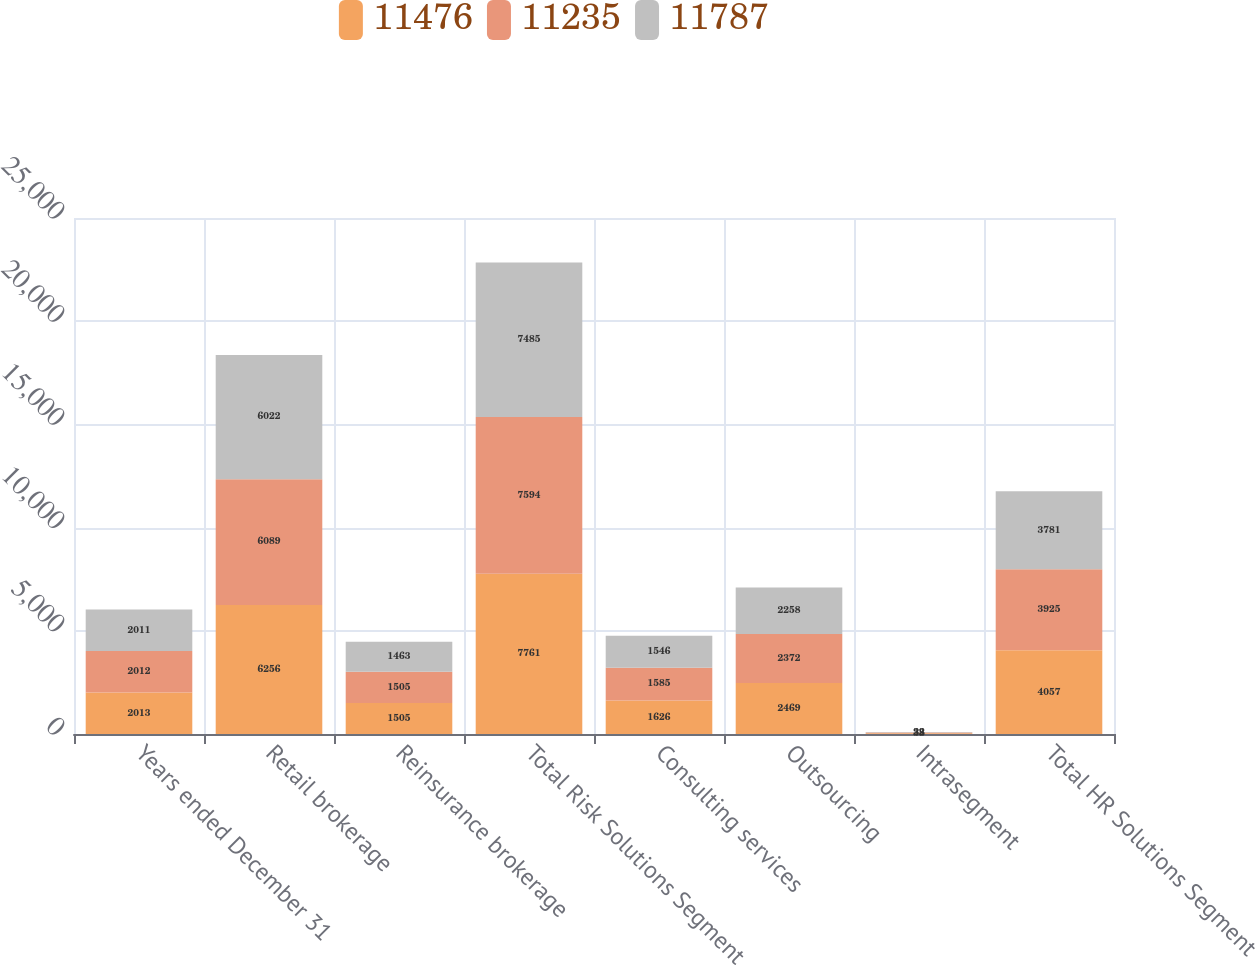Convert chart to OTSL. <chart><loc_0><loc_0><loc_500><loc_500><stacked_bar_chart><ecel><fcel>Years ended December 31<fcel>Retail brokerage<fcel>Reinsurance brokerage<fcel>Total Risk Solutions Segment<fcel>Consulting services<fcel>Outsourcing<fcel>Intrasegment<fcel>Total HR Solutions Segment<nl><fcel>11476<fcel>2013<fcel>6256<fcel>1505<fcel>7761<fcel>1626<fcel>2469<fcel>38<fcel>4057<nl><fcel>11235<fcel>2012<fcel>6089<fcel>1505<fcel>7594<fcel>1585<fcel>2372<fcel>32<fcel>3925<nl><fcel>11787<fcel>2011<fcel>6022<fcel>1463<fcel>7485<fcel>1546<fcel>2258<fcel>23<fcel>3781<nl></chart> 